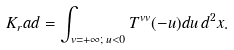Convert formula to latex. <formula><loc_0><loc_0><loc_500><loc_500>K _ { r } a d = \int _ { v = + \infty ; \, u < 0 } T ^ { v v } ( - u ) d u \, d ^ { 2 } x .</formula> 